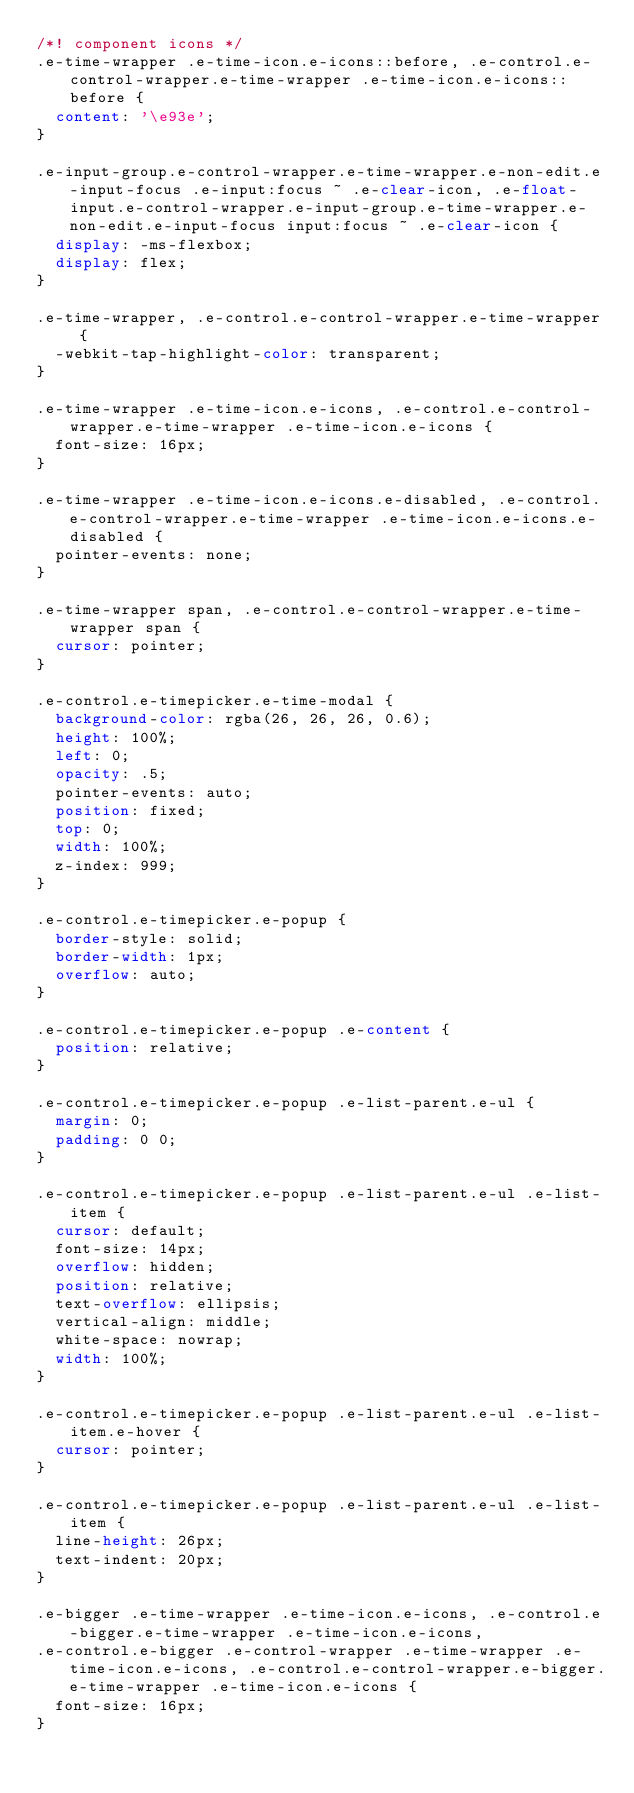Convert code to text. <code><loc_0><loc_0><loc_500><loc_500><_CSS_>/*! component icons */
.e-time-wrapper .e-time-icon.e-icons::before, .e-control.e-control-wrapper.e-time-wrapper .e-time-icon.e-icons::before {
  content: '\e93e';
}

.e-input-group.e-control-wrapper.e-time-wrapper.e-non-edit.e-input-focus .e-input:focus ~ .e-clear-icon, .e-float-input.e-control-wrapper.e-input-group.e-time-wrapper.e-non-edit.e-input-focus input:focus ~ .e-clear-icon {
  display: -ms-flexbox;
  display: flex;
}

.e-time-wrapper, .e-control.e-control-wrapper.e-time-wrapper {
  -webkit-tap-highlight-color: transparent;
}

.e-time-wrapper .e-time-icon.e-icons, .e-control.e-control-wrapper.e-time-wrapper .e-time-icon.e-icons {
  font-size: 16px;
}

.e-time-wrapper .e-time-icon.e-icons.e-disabled, .e-control.e-control-wrapper.e-time-wrapper .e-time-icon.e-icons.e-disabled {
  pointer-events: none;
}

.e-time-wrapper span, .e-control.e-control-wrapper.e-time-wrapper span {
  cursor: pointer;
}

.e-control.e-timepicker.e-time-modal {
  background-color: rgba(26, 26, 26, 0.6);
  height: 100%;
  left: 0;
  opacity: .5;
  pointer-events: auto;
  position: fixed;
  top: 0;
  width: 100%;
  z-index: 999;
}

.e-control.e-timepicker.e-popup {
  border-style: solid;
  border-width: 1px;
  overflow: auto;
}

.e-control.e-timepicker.e-popup .e-content {
  position: relative;
}

.e-control.e-timepicker.e-popup .e-list-parent.e-ul {
  margin: 0;
  padding: 0 0;
}

.e-control.e-timepicker.e-popup .e-list-parent.e-ul .e-list-item {
  cursor: default;
  font-size: 14px;
  overflow: hidden;
  position: relative;
  text-overflow: ellipsis;
  vertical-align: middle;
  white-space: nowrap;
  width: 100%;
}

.e-control.e-timepicker.e-popup .e-list-parent.e-ul .e-list-item.e-hover {
  cursor: pointer;
}

.e-control.e-timepicker.e-popup .e-list-parent.e-ul .e-list-item {
  line-height: 26px;
  text-indent: 20px;
}

.e-bigger .e-time-wrapper .e-time-icon.e-icons, .e-control.e-bigger.e-time-wrapper .e-time-icon.e-icons,
.e-control.e-bigger .e-control-wrapper .e-time-wrapper .e-time-icon.e-icons, .e-control.e-control-wrapper.e-bigger.e-time-wrapper .e-time-icon.e-icons {
  font-size: 16px;
}
</code> 